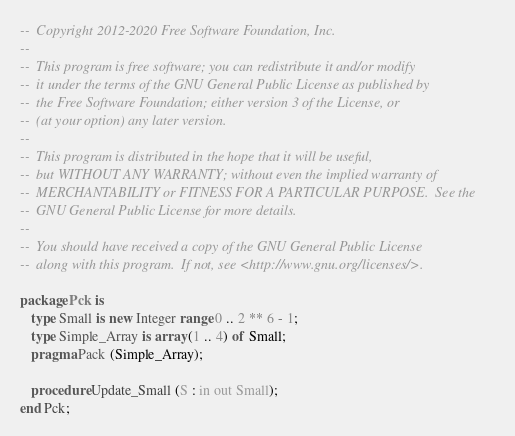<code> <loc_0><loc_0><loc_500><loc_500><_Ada_>--  Copyright 2012-2020 Free Software Foundation, Inc.
--
--  This program is free software; you can redistribute it and/or modify
--  it under the terms of the GNU General Public License as published by
--  the Free Software Foundation; either version 3 of the License, or
--  (at your option) any later version.
--
--  This program is distributed in the hope that it will be useful,
--  but WITHOUT ANY WARRANTY; without even the implied warranty of
--  MERCHANTABILITY or FITNESS FOR A PARTICULAR PURPOSE.  See the
--  GNU General Public License for more details.
--
--  You should have received a copy of the GNU General Public License
--  along with this program.  If not, see <http://www.gnu.org/licenses/>.

package Pck is
   type Small is new Integer range 0 .. 2 ** 6 - 1;
   type Simple_Array is array (1 .. 4) of Small;
   pragma Pack (Simple_Array);

   procedure Update_Small (S : in out Small);
end Pck;
</code> 